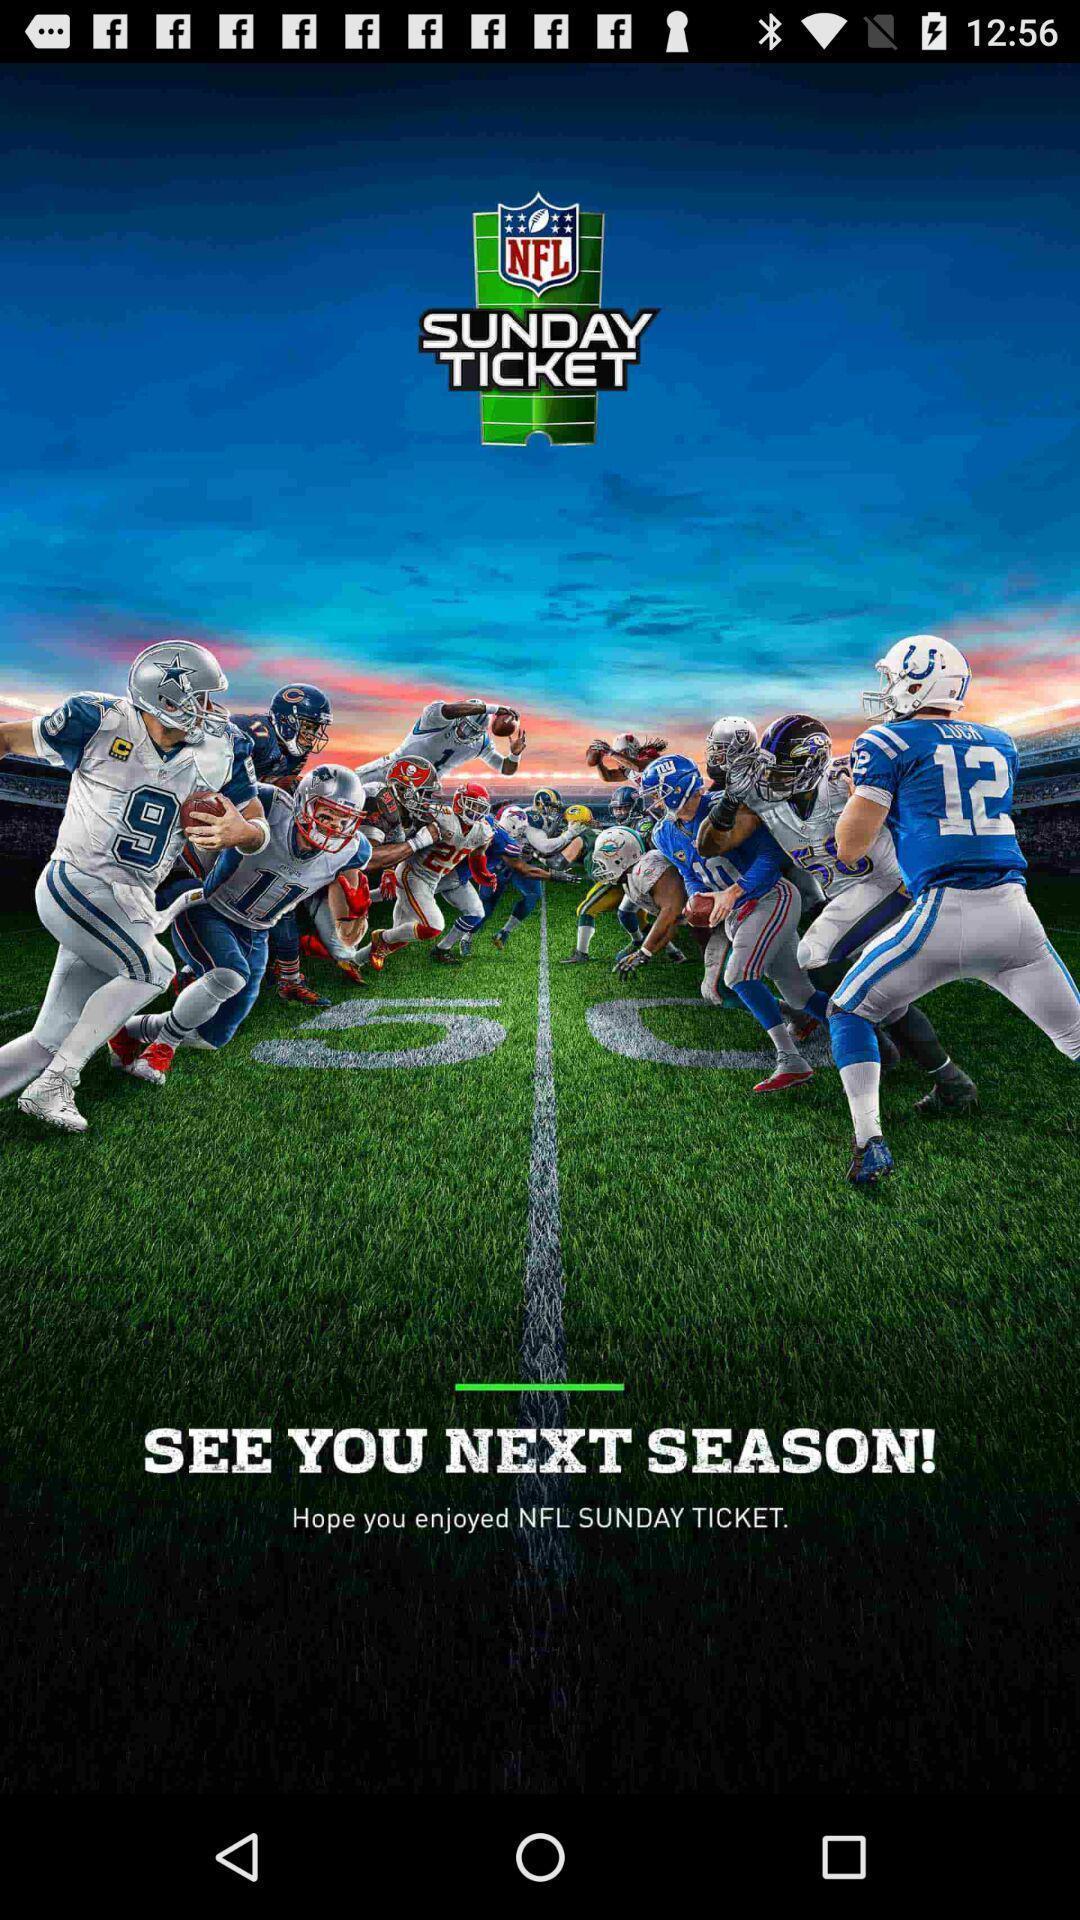What is the overall content of this screenshot? Welcome page of an sport application. 